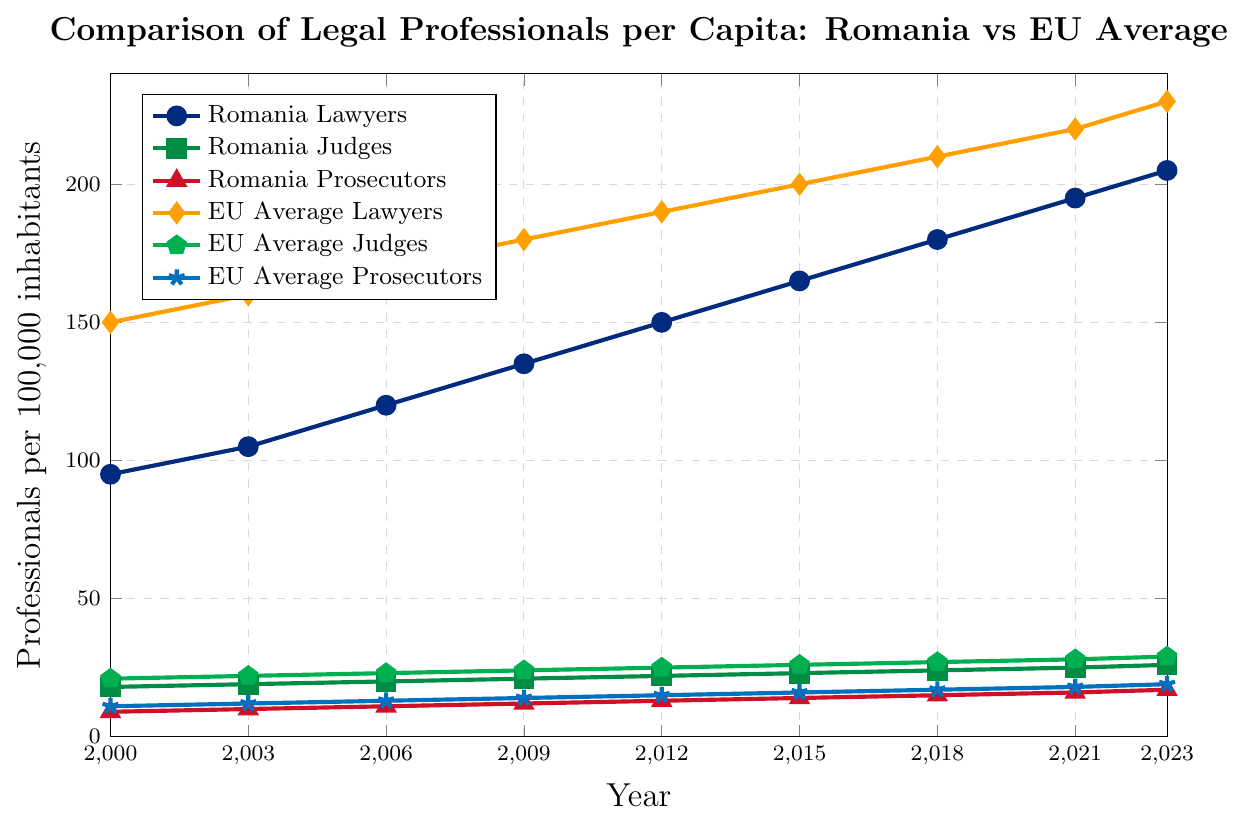Which country had more lawyers per capita in 2000, Romania or the EU average? In 2000, the plot shows Romania had 95 lawyers per capita and the EU average was 150 lawyers per capita. Therefore, the EU had more lawyers per capita.
Answer: EU average Between 2000 and 2023, did the number of judges per capita in Romania increase at a faster rate than the EU average? In 2000, Romania had 18 judges per capita, which increased to 26 in 2023 (an increase of 8). The EU started with 21 judges per capita in 2000 and increased to 29 in 2023 (also an increase of 8). Since both increased by 8, the rates are identical.
Answer: No During which year did the number of prosecutors per capita in Romania reach 15? The figure shows that the number of prosecutors in Romania reached 15 in the year 2018 as indicated by the red line with a triangle marker.
Answer: 2018 What can be inferred about the trend of the number of lawyers per capita in Romania compared to the EU average from 2000 to 2023? The chart indicates an overall upward trend for both Romania and the EU average for lawyers per capita. However, Romania consistently has fewer lawyers per capita compared to the EU average throughout this period, with both increasing steadily.
Answer: Upward trend, fewer in Romania By what percentage did the number of judges per capita increase in Romania from 2000 to 2023? Initially, Romania had 18 judges per capita in 2000 and 26 in 2023. The increase is calculated as (26 - 18) / 18 * 100% = 44.44%.
Answer: 44.44% What is the difference in the number of lawyers per capita between Romania and the EU average in 2023? In 2023, Romania had 205 lawyers per capita while the EU average was 230. The difference is 230 - 205 = 25.
Answer: 25 Are there any professions where Romania and the EU average show similar growth trends from 2000 to 2023? Both Romania and the EU average show similar trends in the number of judges and prosecutors per capita. Each profession increases steadily over time, with the final values for judges (26 in Romania, 29 in the EU) and prosecutors (17 in Romania, 19 in the EU) being close to each other.
Answer: Judges and Prosecutors In which year did the number of lawyers per capita in Romania surpass 150? Referring to the blue line with circle markers, it can be observed that the number of lawyers per capita in Romania surpassed 150 in the year 2012.
Answer: 2012 Which profession had the smallest difference in per capita numbers between Romania and the EU average in 2023? In 2023, the difference can be calculated as follows: Lawyers: 230 - 205 = 25, Judges: 29 - 26 = 3, Prosecutors: 19 - 17 = 2. Therefore, the smallest difference is for prosecutors.
Answer: Prosecutors 